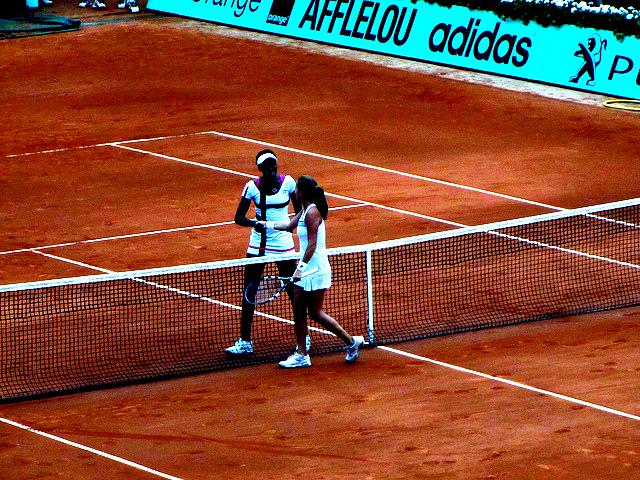Is there any significance to the apparel of the players? The players are wearing professional tennis attire, which is designed for performance and comfort during matches. Typically, sponsorships and branding may also be visible, representing professional engagement with tennis as a sport. The attire can sometimes give clues about when the photo was taken based on styles or sponsorship deals of certain time periods. Can the image inform us about the event or location? Given that the surface is clay and the perimeter advertising includes known sponsors, the image may be from a professional tennis tournament that features clay courts, such as the French Open. The exact event, however, cannot be confirmed without additional context. 